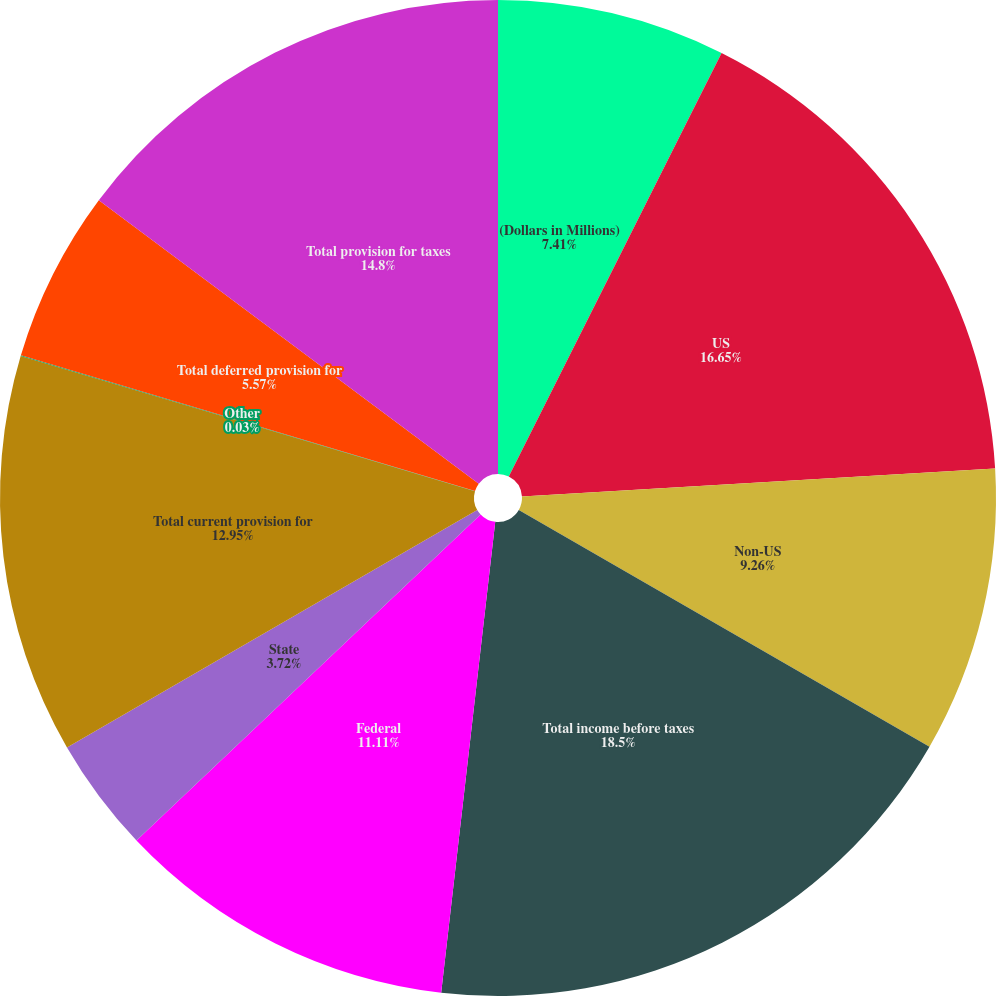Convert chart to OTSL. <chart><loc_0><loc_0><loc_500><loc_500><pie_chart><fcel>(Dollars in Millions)<fcel>US<fcel>Non-US<fcel>Total income before taxes<fcel>Federal<fcel>State<fcel>Total current provision for<fcel>Other<fcel>Total deferred provision for<fcel>Total provision for taxes<nl><fcel>7.41%<fcel>16.65%<fcel>9.26%<fcel>18.5%<fcel>11.11%<fcel>3.72%<fcel>12.95%<fcel>0.03%<fcel>5.57%<fcel>14.8%<nl></chart> 